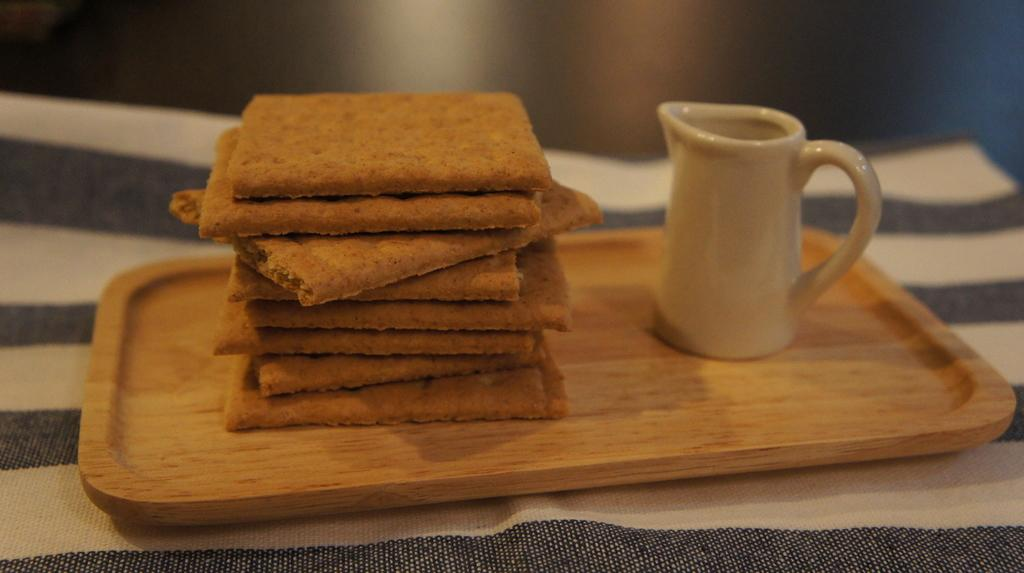What type of items can be seen on the tray in the image? There are food items and a coffee mug on the tray in the image. What is the purpose of the coffee mug in the image? The coffee mug is likely for holding a beverage, such as coffee. What is the surface that the tray is placed on in the image? There is cloth on a table in the image, which is likely the surface where the tray is placed. What color is the sign that is visible in the image? There is no sign present in the image; it only features food items, a coffee mug, a tray, and a table with cloth. 